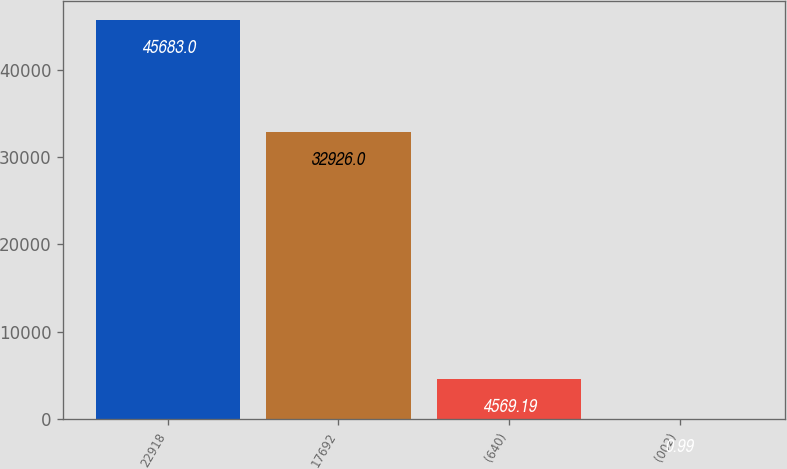<chart> <loc_0><loc_0><loc_500><loc_500><bar_chart><fcel>22918<fcel>17692<fcel>(640)<fcel>(002)<nl><fcel>45683<fcel>32926<fcel>4569.19<fcel>0.99<nl></chart> 